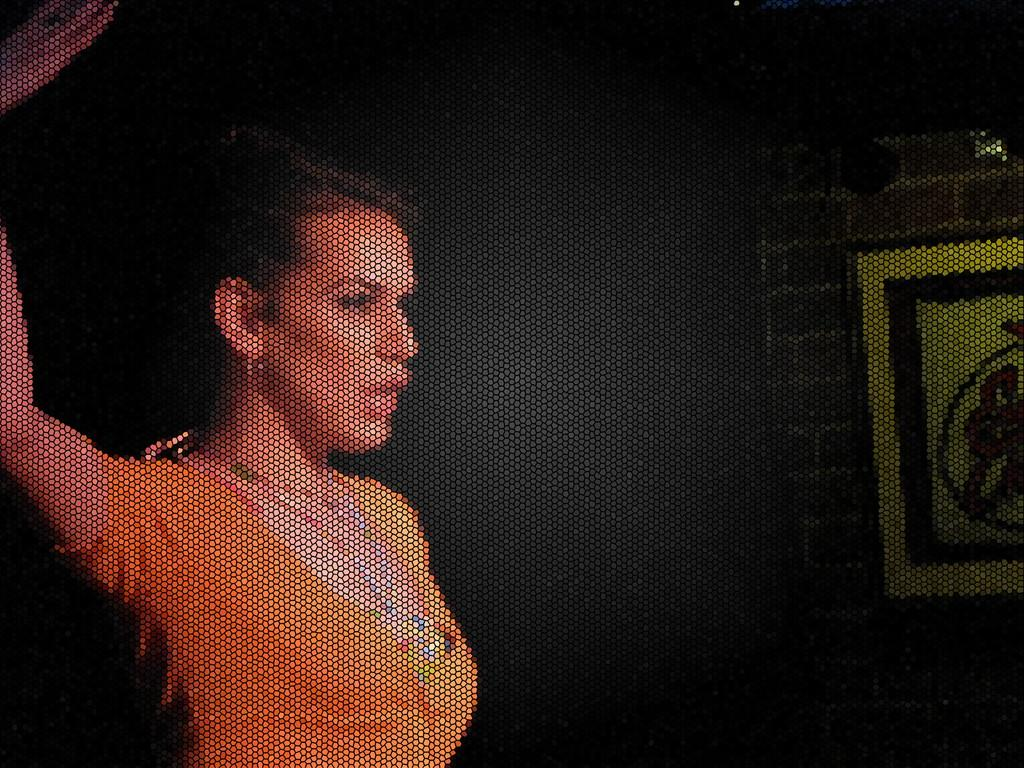Who or what is present in the image? There is a person in the image. What is the person wearing? The person is wearing a brown dress. What can be seen in the background of the image? There is a frame attached to the wall in the background of the image. How many geese are visible in the image? There are no geese present in the image. What type of yak can be seen in the image? There is no yak present in the image. 